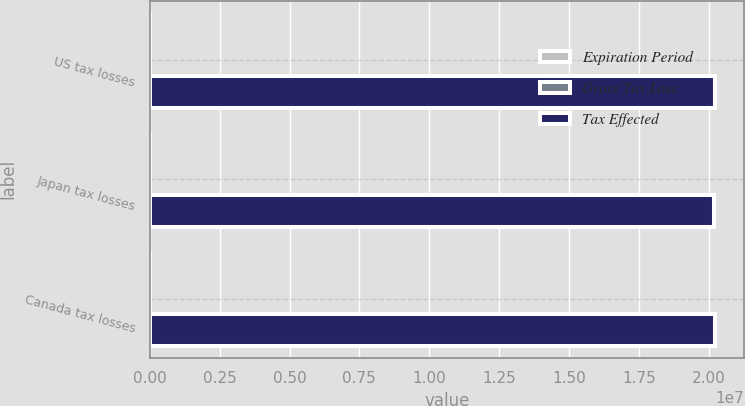Convert chart to OTSL. <chart><loc_0><loc_0><loc_500><loc_500><stacked_bar_chart><ecel><fcel>US tax losses<fcel>Japan tax losses<fcel>Canada tax losses<nl><fcel>Expiration Period<fcel>73<fcel>102<fcel>46<nl><fcel>Gross Tax Loss<fcel>15<fcel>32<fcel>12<nl><fcel>Tax Effected<fcel>2.0222e+07<fcel>2.0192e+07<fcel>2.0242e+07<nl></chart> 